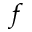Convert formula to latex. <formula><loc_0><loc_0><loc_500><loc_500>f</formula> 